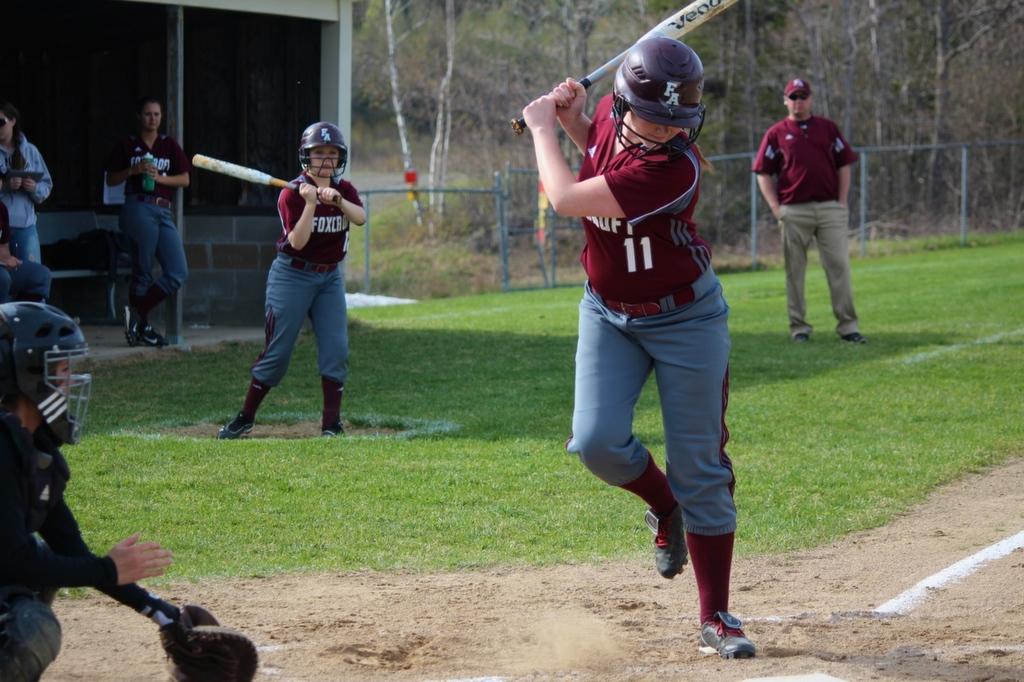What number player is up to bat?
Provide a succinct answer. 11. What is the letters on the batting helmet?
Offer a very short reply. Fa. 